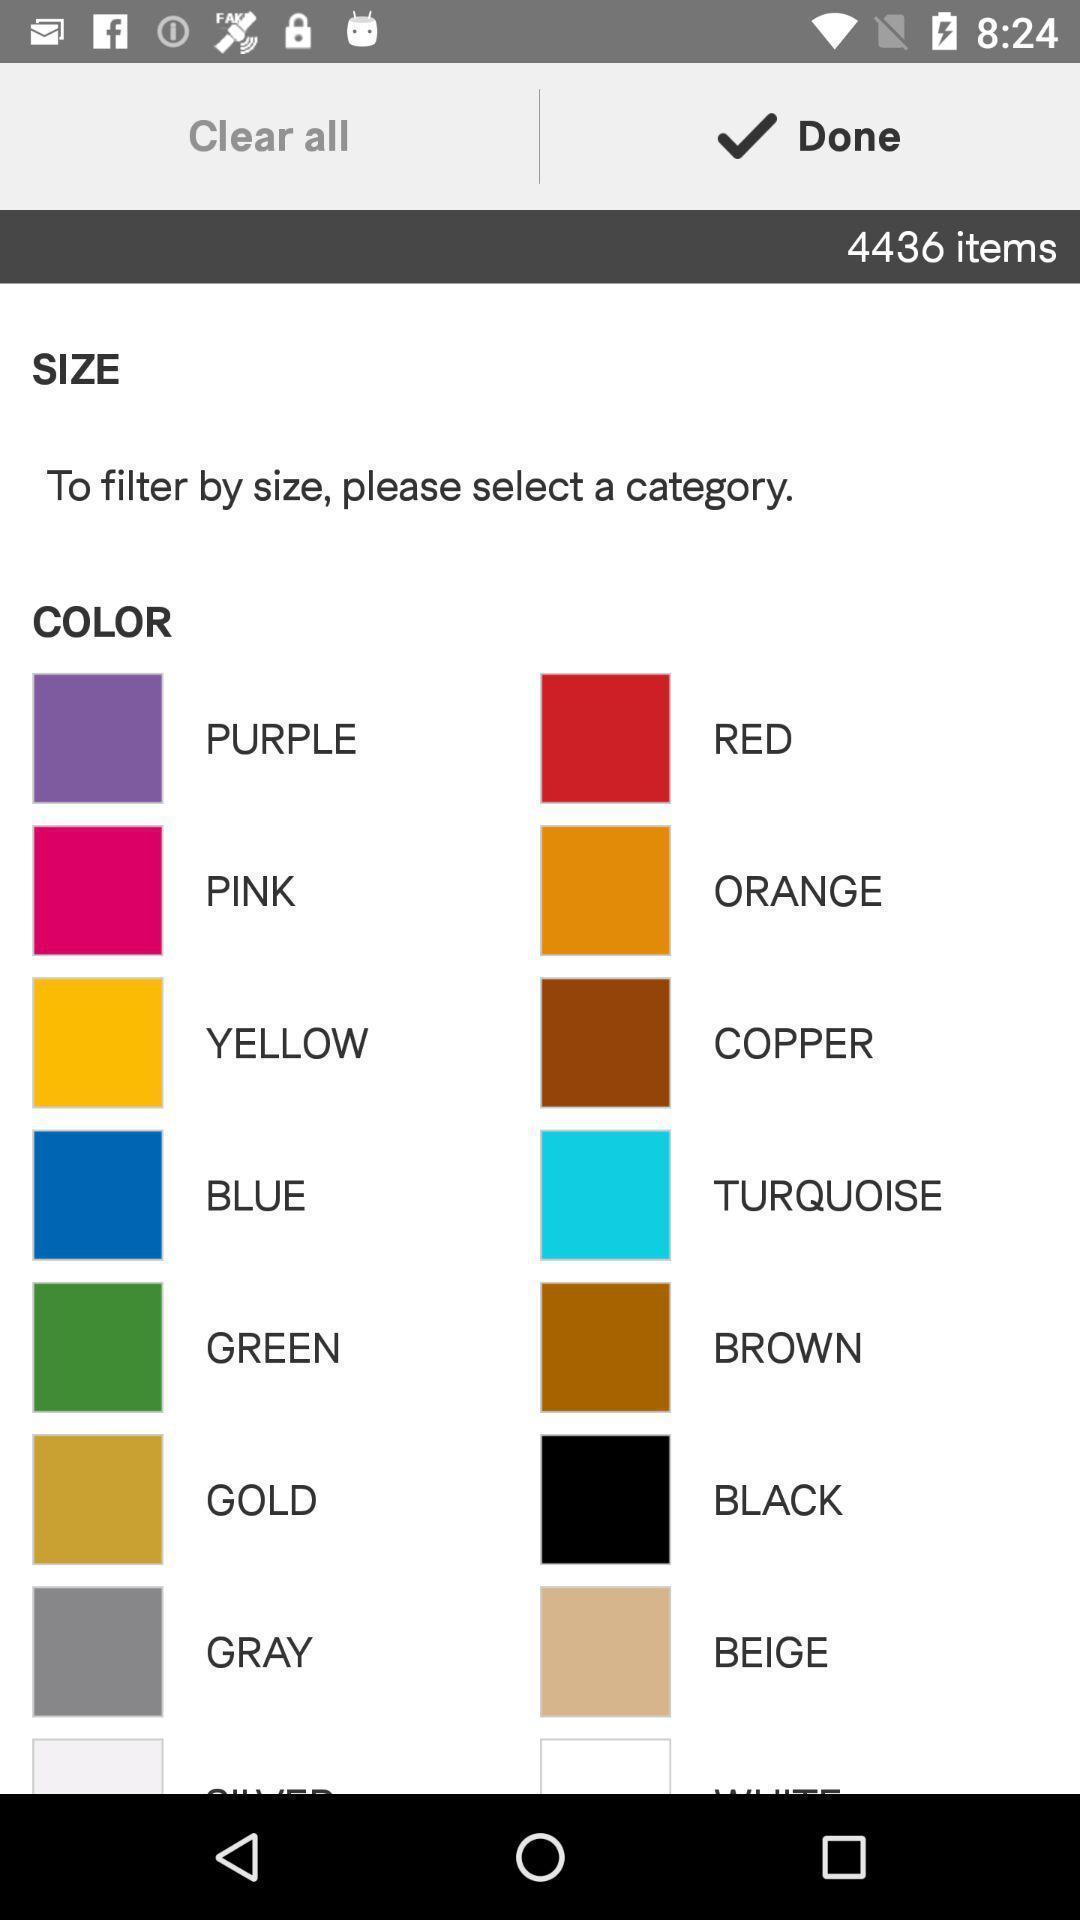Explain what's happening in this screen capture. Page showing list of colors in app. 